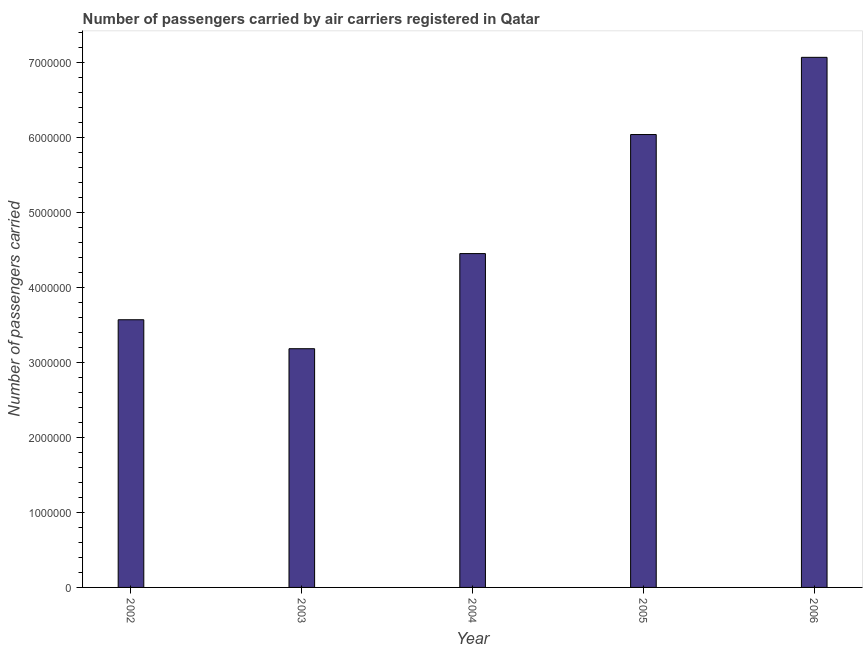What is the title of the graph?
Offer a very short reply. Number of passengers carried by air carriers registered in Qatar. What is the label or title of the Y-axis?
Offer a terse response. Number of passengers carried. What is the number of passengers carried in 2005?
Offer a terse response. 6.04e+06. Across all years, what is the maximum number of passengers carried?
Give a very brief answer. 7.07e+06. Across all years, what is the minimum number of passengers carried?
Make the answer very short. 3.18e+06. In which year was the number of passengers carried maximum?
Make the answer very short. 2006. What is the sum of the number of passengers carried?
Your answer should be compact. 2.43e+07. What is the difference between the number of passengers carried in 2005 and 2006?
Provide a succinct answer. -1.03e+06. What is the average number of passengers carried per year?
Make the answer very short. 4.86e+06. What is the median number of passengers carried?
Your response must be concise. 4.45e+06. Do a majority of the years between 2004 and 2005 (inclusive) have number of passengers carried greater than 6400000 ?
Provide a succinct answer. No. What is the ratio of the number of passengers carried in 2003 to that in 2006?
Keep it short and to the point. 0.45. Is the difference between the number of passengers carried in 2002 and 2005 greater than the difference between any two years?
Offer a very short reply. No. What is the difference between the highest and the second highest number of passengers carried?
Ensure brevity in your answer.  1.03e+06. Is the sum of the number of passengers carried in 2003 and 2006 greater than the maximum number of passengers carried across all years?
Keep it short and to the point. Yes. What is the difference between the highest and the lowest number of passengers carried?
Provide a short and direct response. 3.89e+06. In how many years, is the number of passengers carried greater than the average number of passengers carried taken over all years?
Offer a terse response. 2. How many years are there in the graph?
Offer a very short reply. 5. What is the difference between two consecutive major ticks on the Y-axis?
Ensure brevity in your answer.  1.00e+06. What is the Number of passengers carried of 2002?
Make the answer very short. 3.57e+06. What is the Number of passengers carried in 2003?
Your answer should be compact. 3.18e+06. What is the Number of passengers carried of 2004?
Ensure brevity in your answer.  4.45e+06. What is the Number of passengers carried of 2005?
Offer a terse response. 6.04e+06. What is the Number of passengers carried of 2006?
Give a very brief answer. 7.07e+06. What is the difference between the Number of passengers carried in 2002 and 2003?
Ensure brevity in your answer.  3.86e+05. What is the difference between the Number of passengers carried in 2002 and 2004?
Your response must be concise. -8.83e+05. What is the difference between the Number of passengers carried in 2002 and 2005?
Provide a succinct answer. -2.47e+06. What is the difference between the Number of passengers carried in 2002 and 2006?
Provide a succinct answer. -3.50e+06. What is the difference between the Number of passengers carried in 2003 and 2004?
Your answer should be very brief. -1.27e+06. What is the difference between the Number of passengers carried in 2003 and 2005?
Provide a succinct answer. -2.86e+06. What is the difference between the Number of passengers carried in 2003 and 2006?
Your response must be concise. -3.89e+06. What is the difference between the Number of passengers carried in 2004 and 2005?
Keep it short and to the point. -1.59e+06. What is the difference between the Number of passengers carried in 2004 and 2006?
Provide a succinct answer. -2.62e+06. What is the difference between the Number of passengers carried in 2005 and 2006?
Keep it short and to the point. -1.03e+06. What is the ratio of the Number of passengers carried in 2002 to that in 2003?
Offer a terse response. 1.12. What is the ratio of the Number of passengers carried in 2002 to that in 2004?
Your response must be concise. 0.8. What is the ratio of the Number of passengers carried in 2002 to that in 2005?
Your response must be concise. 0.59. What is the ratio of the Number of passengers carried in 2002 to that in 2006?
Your answer should be very brief. 0.51. What is the ratio of the Number of passengers carried in 2003 to that in 2004?
Provide a succinct answer. 0.71. What is the ratio of the Number of passengers carried in 2003 to that in 2005?
Ensure brevity in your answer.  0.53. What is the ratio of the Number of passengers carried in 2003 to that in 2006?
Your response must be concise. 0.45. What is the ratio of the Number of passengers carried in 2004 to that in 2005?
Ensure brevity in your answer.  0.74. What is the ratio of the Number of passengers carried in 2004 to that in 2006?
Your answer should be compact. 0.63. What is the ratio of the Number of passengers carried in 2005 to that in 2006?
Keep it short and to the point. 0.85. 